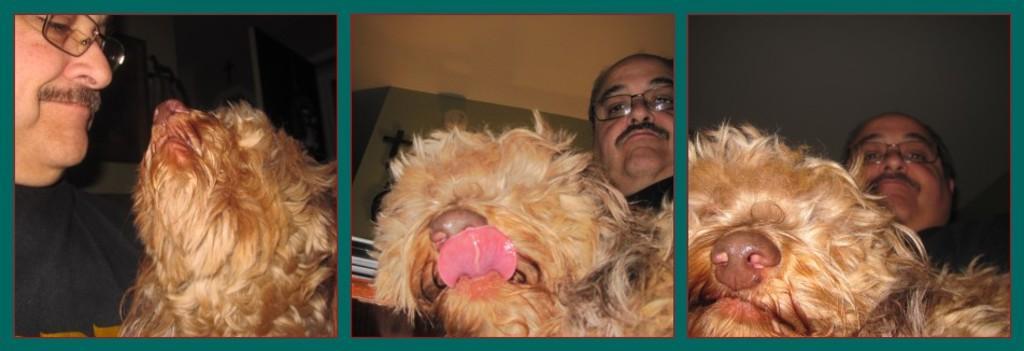Could you give a brief overview of what you see in this image? In this image we can see a collage. On all images we can see a person wearing specs and an animal. 